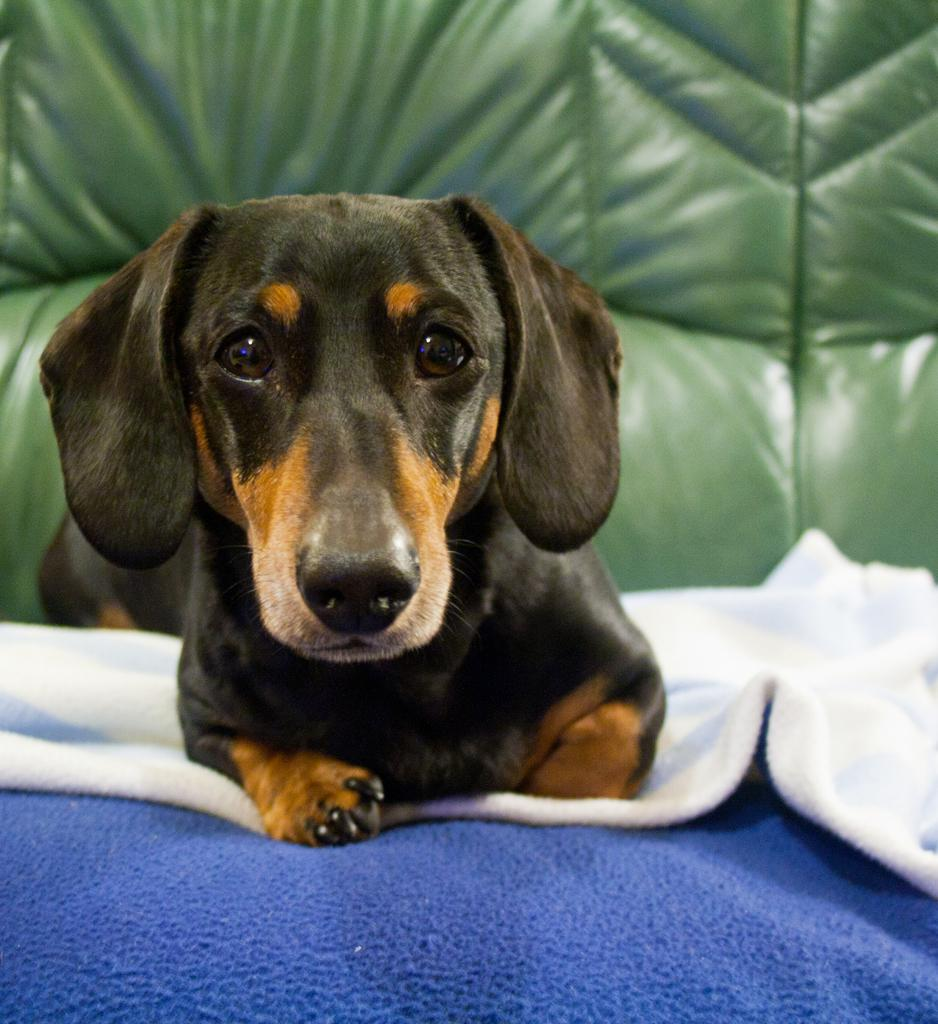What type of animal is in the image? There is a black dog in the image. Where is the dog located? The dog is on a sofa or a bed. What colors are the blankets at the bottom of the image? The blankets are in white and blue color. What can be seen in the background of the image? There is a green sofa in the background of the image. What is the price of the soda being sold in the image? There is no soda being sold in the image; it features a black dog on a sofa or a bed with blankets and a green sofa in the background. 